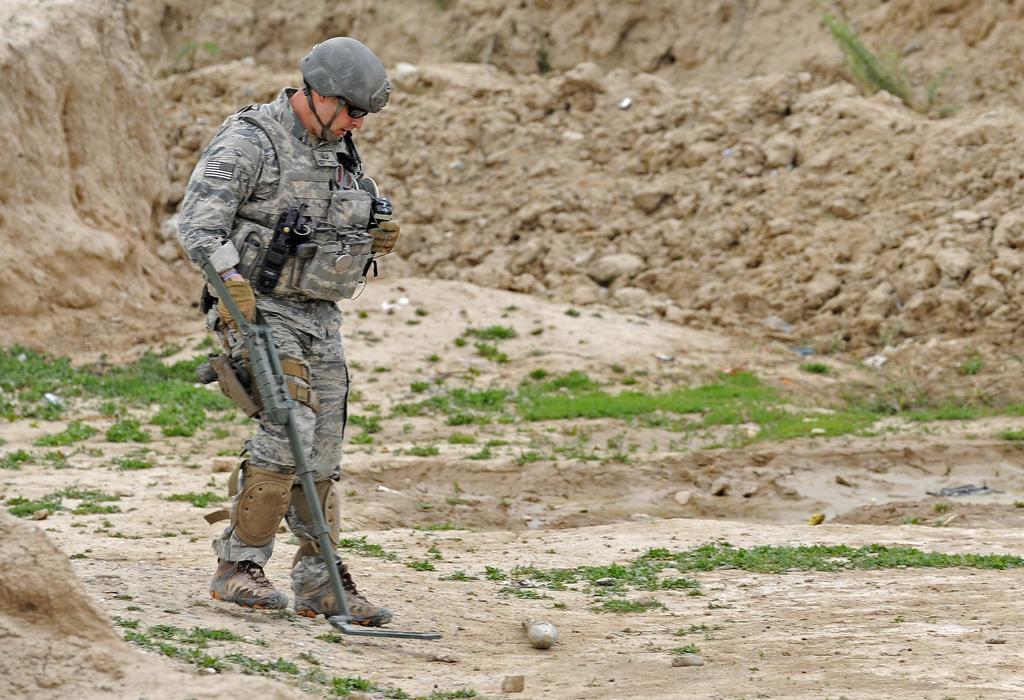Can you describe this image briefly? In this picture there is a man holding the object and he is walking. At the back there is mud. At the bottom there is grass. 